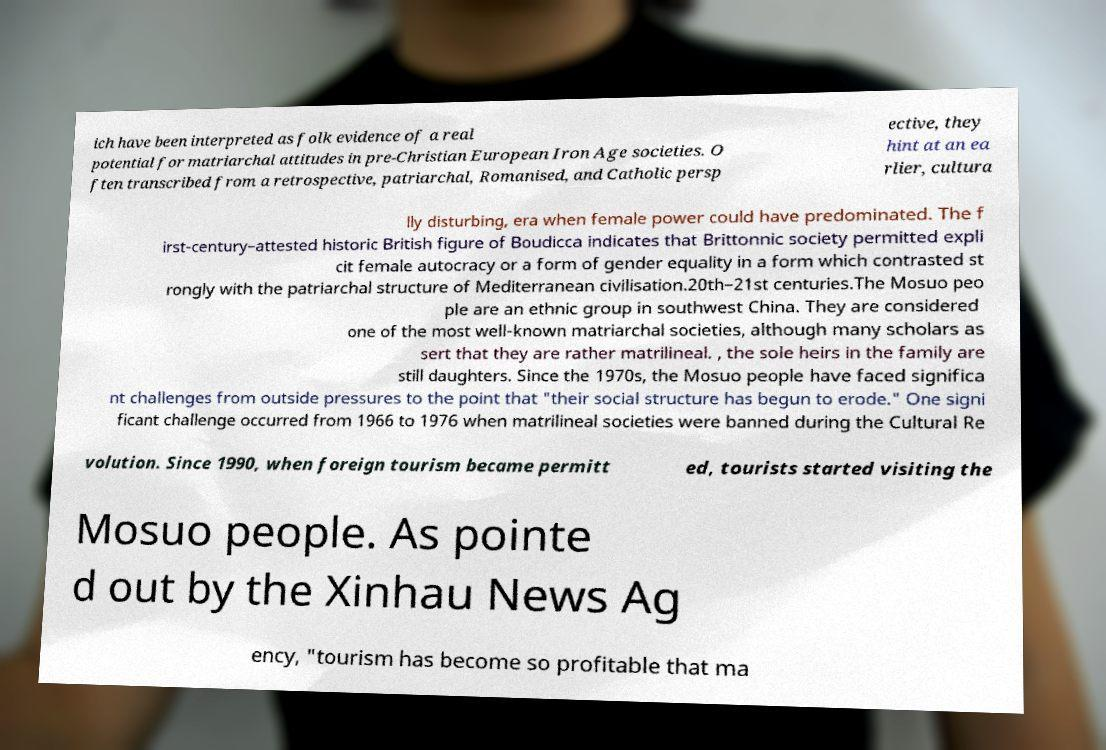Can you accurately transcribe the text from the provided image for me? ich have been interpreted as folk evidence of a real potential for matriarchal attitudes in pre-Christian European Iron Age societies. O ften transcribed from a retrospective, patriarchal, Romanised, and Catholic persp ective, they hint at an ea rlier, cultura lly disturbing, era when female power could have predominated. The f irst-century–attested historic British figure of Boudicca indicates that Brittonnic society permitted expli cit female autocracy or a form of gender equality in a form which contrasted st rongly with the patriarchal structure of Mediterranean civilisation.20th–21st centuries.The Mosuo peo ple are an ethnic group in southwest China. They are considered one of the most well-known matriarchal societies, although many scholars as sert that they are rather matrilineal. , the sole heirs in the family are still daughters. Since the 1970s, the Mosuo people have faced significa nt challenges from outside pressures to the point that "their social structure has begun to erode." One signi ficant challenge occurred from 1966 to 1976 when matrilineal societies were banned during the Cultural Re volution. Since 1990, when foreign tourism became permitt ed, tourists started visiting the Mosuo people. As pointe d out by the Xinhau News Ag ency, "tourism has become so profitable that ma 